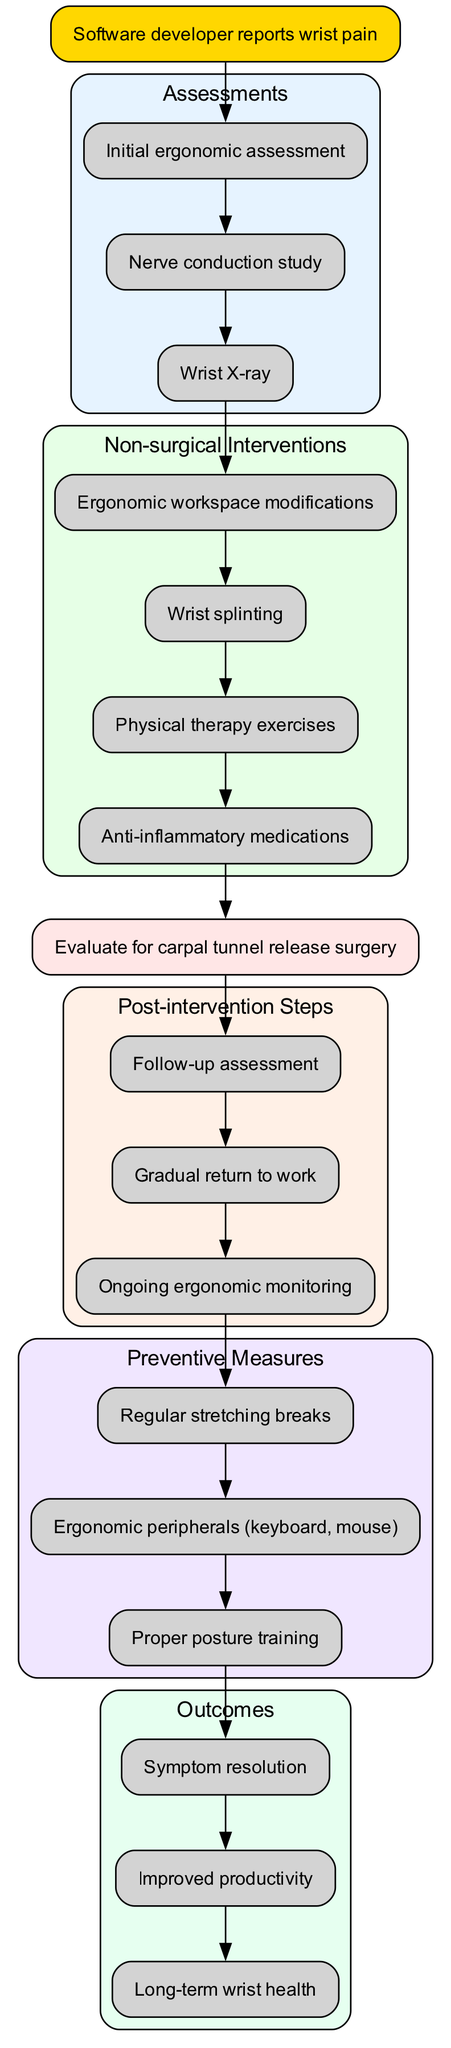What is the starting point of the clinical pathway? The starting point, as seen in the diagram, is "Software developer reports wrist pain." This is the first node and indicates where the clinical pathway begins.
Answer: Software developer reports wrist pain How many non-surgical interventions are listed in the pathway? There are four non-surgical interventions represented in the diagram: "Ergonomic workspace modifications," "Wrist splinting," "Physical therapy exercises," and "Anti-inflammatory medications." These are grouped under a specific subgraph for non-surgical interventions.
Answer: 4 What follows the nerve conduction study in the clinical pathway? According to the diagram, after the "Nerve conduction study," the next step is the "Wrist X-ray." This can be seen from the directed edge that links these two assessments sequentially.
Answer: Wrist X-ray Which node represents potential surgical intervention? The node labeled "Evaluate for carpal tunnel release surgery" represents the potential surgical intervention. This node is distinctly colored and positioned after the non-surgical interventions.
Answer: Evaluate for carpal tunnel release surgery What post-intervention step occurs immediately after surgery evaluation? The first post-intervention step after the surgical consideration is "Follow-up assessment." This is directly linked in the flow from the surgical evaluation node.
Answer: Follow-up assessment What type of measures are included for prevention in the pathway? The preventive measures include "Regular stretching breaks," "Ergonomic peripherals (keyboard, mouse)," and "Proper posture training." These are grouped under a specific section dedicated to preventive measures within the diagram.
Answer: Regular stretching breaks, Ergonomic peripherals (keyboard, mouse), Proper posture training How many outcomes are specified after the post-intervention steps? The diagram specifies three outcomes that result from following the clinical pathway: "Symptom resolution," "Improved productivity," and "Long-term wrist health." Each outcome is grouped within its own section in the diagram.
Answer: 3 What relationship exists between the post-intervention steps and preventive measures? The relationship indicates that after completing the post-intervention steps, the diagram recommends moving into the preventive measures. The directed edge flows from the last post-intervention step to the first preventive measure node.
Answer: Followed by What color represents the assessments in the diagram? The assessments are represented with a light blue fill color (hex code #E6F3FF). This color is used for the subgraph that contains all assessment nodes, differentiating it from other sections.
Answer: Light blue 